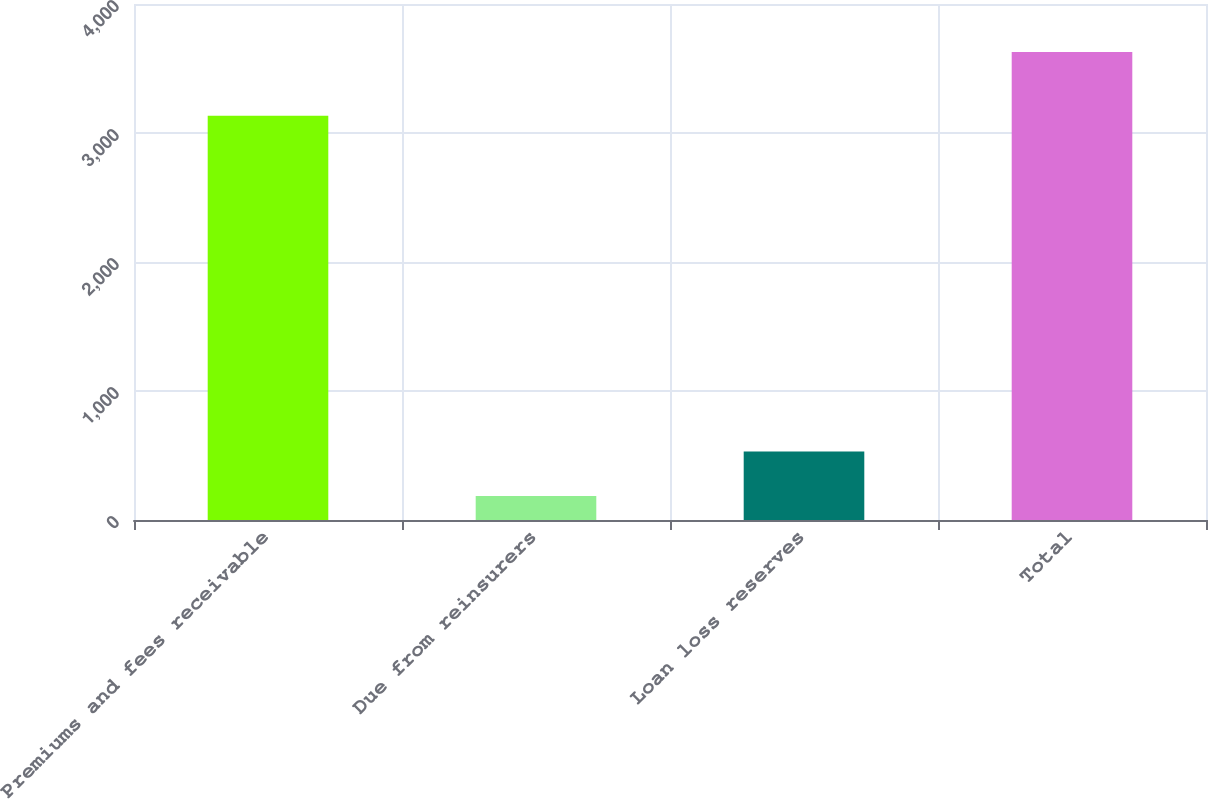Convert chart. <chart><loc_0><loc_0><loc_500><loc_500><bar_chart><fcel>Premiums and fees receivable<fcel>Due from reinsurers<fcel>Loan loss reserves<fcel>Total<nl><fcel>3133<fcel>186<fcel>530.1<fcel>3627<nl></chart> 